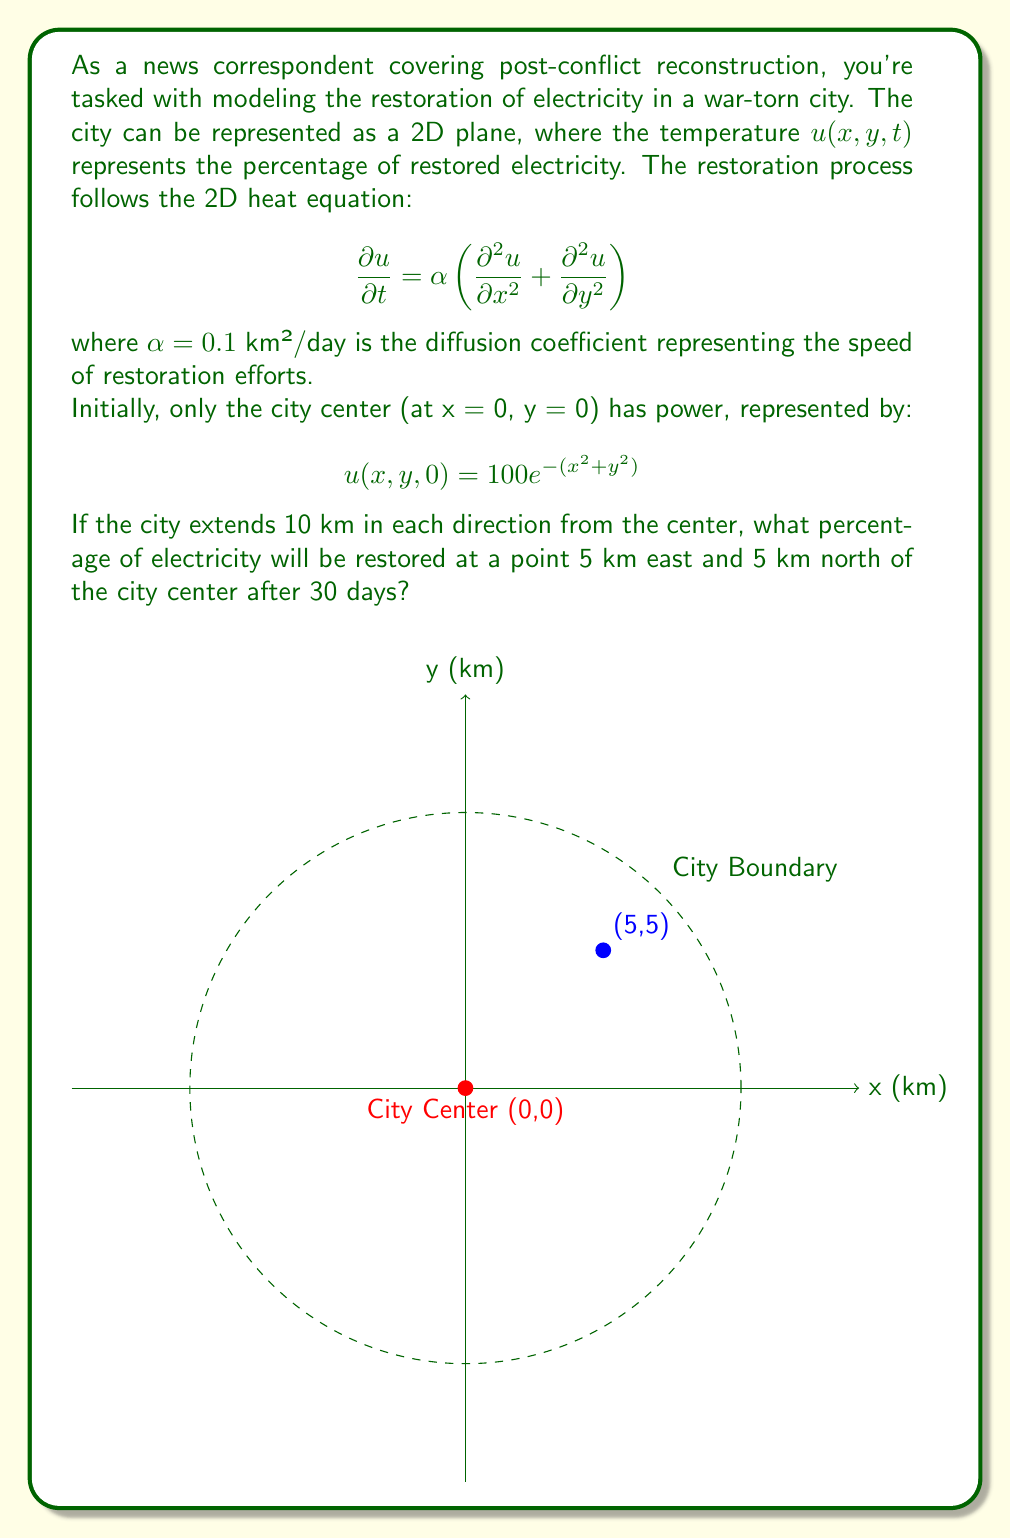Give your solution to this math problem. To solve this problem, we need to use the solution to the 2D heat equation with an initial point source. The solution is given by:

$$u(x,y,t) = \frac{M}{4\pi\alpha t}e^{-\frac{x^2+y^2}{4\alpha t}}$$

where $M$ is the initial total amount of heat (in our case, electricity).

Steps to solve:

1) First, we need to find $M$. Integrate the initial condition over the entire plane:

   $$M = \int_{-\infty}^{\infty}\int_{-\infty}^{\infty} 100e^{-(x^2+y^2)} dx dy = 100\pi$$

2) Now we can plug in our values:
   - $\alpha = 0.1$ km²/day
   - $t = 30$ days
   - $x = 5$ km
   - $y = 5$ km
   - $M = 100\pi$

3) Substituting into the solution equation:

   $$u(5,5,30) = \frac{100\pi}{4\pi(0.1)(30)}e^{-\frac{5^2+5^2}{4(0.1)(30)}}$$

4) Simplify:
   
   $$u(5,5,30) = \frac{25}{3}e^{-\frac{50}{12}} \approx 0.3047$$

5) Convert to percentage:

   $0.3047 * 100\% \approx 30.47\%$
Answer: 30.47% 